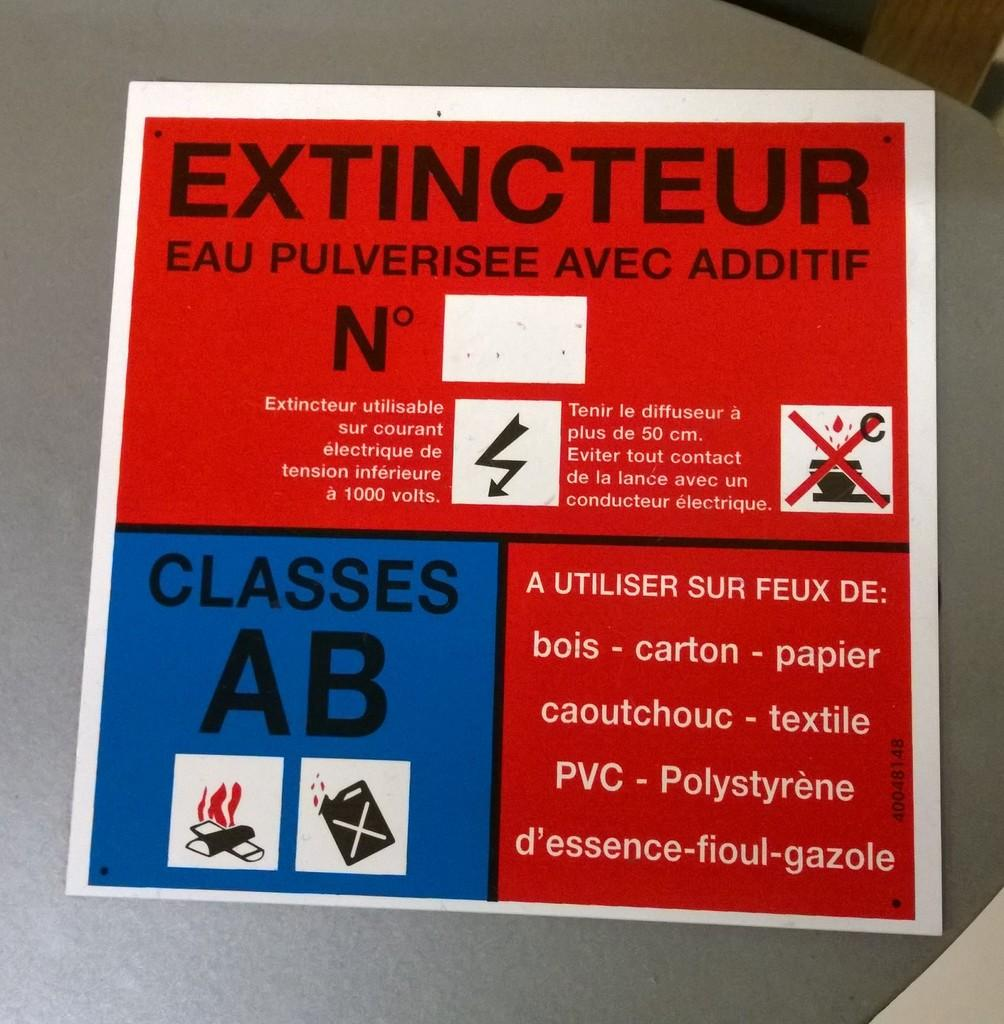What can be seen in the image related to advertising or information? There is a poster in the image. What colors are used in the poster? The poster has a color combination of red, black, and violet. What is the poster attached to in the image? The poster is pasted on an object. What is the color of the object the poster is attached to? The object is gray in color. How many visitors can be seen interacting with the pen in the image? There are no visitors or pens present in the image. What specific detail is visible on the poster in the image? The provided facts do not mention any specific details on the poster; only the color combination is mentioned. 